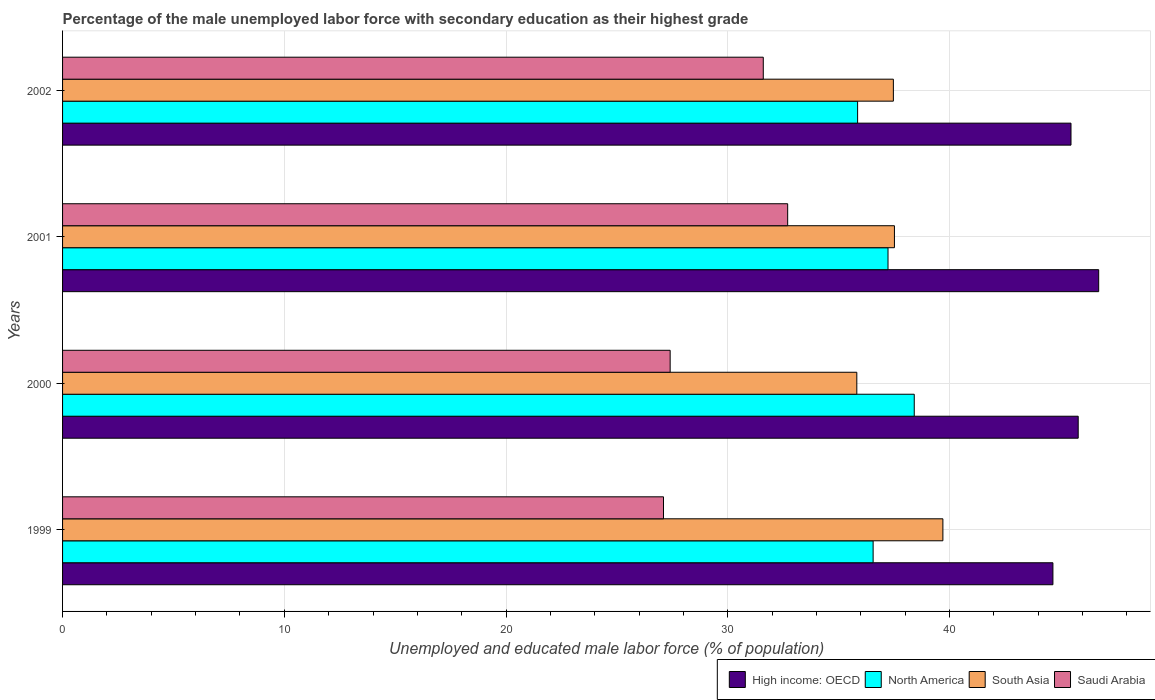How many different coloured bars are there?
Your answer should be compact. 4. In how many cases, is the number of bars for a given year not equal to the number of legend labels?
Make the answer very short. 0. What is the percentage of the unemployed male labor force with secondary education in High income: OECD in 2002?
Make the answer very short. 45.48. Across all years, what is the maximum percentage of the unemployed male labor force with secondary education in Saudi Arabia?
Ensure brevity in your answer.  32.7. Across all years, what is the minimum percentage of the unemployed male labor force with secondary education in Saudi Arabia?
Keep it short and to the point. 27.1. In which year was the percentage of the unemployed male labor force with secondary education in Saudi Arabia minimum?
Your response must be concise. 1999. What is the total percentage of the unemployed male labor force with secondary education in Saudi Arabia in the graph?
Your response must be concise. 118.8. What is the difference between the percentage of the unemployed male labor force with secondary education in Saudi Arabia in 2000 and that in 2001?
Keep it short and to the point. -5.3. What is the difference between the percentage of the unemployed male labor force with secondary education in High income: OECD in 2001 and the percentage of the unemployed male labor force with secondary education in South Asia in 1999?
Provide a succinct answer. 7.03. What is the average percentage of the unemployed male labor force with secondary education in Saudi Arabia per year?
Your response must be concise. 29.7. In the year 2002, what is the difference between the percentage of the unemployed male labor force with secondary education in Saudi Arabia and percentage of the unemployed male labor force with secondary education in South Asia?
Make the answer very short. -5.87. In how many years, is the percentage of the unemployed male labor force with secondary education in High income: OECD greater than 30 %?
Provide a succinct answer. 4. What is the ratio of the percentage of the unemployed male labor force with secondary education in North America in 1999 to that in 2002?
Provide a succinct answer. 1.02. What is the difference between the highest and the second highest percentage of the unemployed male labor force with secondary education in High income: OECD?
Your response must be concise. 0.92. What is the difference between the highest and the lowest percentage of the unemployed male labor force with secondary education in Saudi Arabia?
Offer a very short reply. 5.6. Is it the case that in every year, the sum of the percentage of the unemployed male labor force with secondary education in South Asia and percentage of the unemployed male labor force with secondary education in Saudi Arabia is greater than the sum of percentage of the unemployed male labor force with secondary education in North America and percentage of the unemployed male labor force with secondary education in High income: OECD?
Your response must be concise. No. What does the 4th bar from the top in 1999 represents?
Provide a succinct answer. High income: OECD. Is it the case that in every year, the sum of the percentage of the unemployed male labor force with secondary education in Saudi Arabia and percentage of the unemployed male labor force with secondary education in High income: OECD is greater than the percentage of the unemployed male labor force with secondary education in North America?
Give a very brief answer. Yes. Are all the bars in the graph horizontal?
Offer a very short reply. Yes. How many years are there in the graph?
Your answer should be very brief. 4. Does the graph contain any zero values?
Your answer should be very brief. No. Does the graph contain grids?
Provide a succinct answer. Yes. How many legend labels are there?
Offer a terse response. 4. How are the legend labels stacked?
Offer a very short reply. Horizontal. What is the title of the graph?
Your answer should be compact. Percentage of the male unemployed labor force with secondary education as their highest grade. What is the label or title of the X-axis?
Your answer should be very brief. Unemployed and educated male labor force (% of population). What is the label or title of the Y-axis?
Offer a terse response. Years. What is the Unemployed and educated male labor force (% of population) in High income: OECD in 1999?
Provide a short and direct response. 44.66. What is the Unemployed and educated male labor force (% of population) of North America in 1999?
Make the answer very short. 36.55. What is the Unemployed and educated male labor force (% of population) in South Asia in 1999?
Your response must be concise. 39.7. What is the Unemployed and educated male labor force (% of population) of Saudi Arabia in 1999?
Offer a very short reply. 27.1. What is the Unemployed and educated male labor force (% of population) of High income: OECD in 2000?
Provide a succinct answer. 45.8. What is the Unemployed and educated male labor force (% of population) of North America in 2000?
Give a very brief answer. 38.41. What is the Unemployed and educated male labor force (% of population) of South Asia in 2000?
Ensure brevity in your answer.  35.82. What is the Unemployed and educated male labor force (% of population) of Saudi Arabia in 2000?
Keep it short and to the point. 27.4. What is the Unemployed and educated male labor force (% of population) of High income: OECD in 2001?
Ensure brevity in your answer.  46.73. What is the Unemployed and educated male labor force (% of population) of North America in 2001?
Make the answer very short. 37.22. What is the Unemployed and educated male labor force (% of population) in South Asia in 2001?
Make the answer very short. 37.52. What is the Unemployed and educated male labor force (% of population) of Saudi Arabia in 2001?
Your response must be concise. 32.7. What is the Unemployed and educated male labor force (% of population) of High income: OECD in 2002?
Give a very brief answer. 45.48. What is the Unemployed and educated male labor force (% of population) of North America in 2002?
Offer a terse response. 35.85. What is the Unemployed and educated male labor force (% of population) of South Asia in 2002?
Give a very brief answer. 37.47. What is the Unemployed and educated male labor force (% of population) of Saudi Arabia in 2002?
Provide a succinct answer. 31.6. Across all years, what is the maximum Unemployed and educated male labor force (% of population) of High income: OECD?
Ensure brevity in your answer.  46.73. Across all years, what is the maximum Unemployed and educated male labor force (% of population) in North America?
Give a very brief answer. 38.41. Across all years, what is the maximum Unemployed and educated male labor force (% of population) of South Asia?
Offer a terse response. 39.7. Across all years, what is the maximum Unemployed and educated male labor force (% of population) in Saudi Arabia?
Ensure brevity in your answer.  32.7. Across all years, what is the minimum Unemployed and educated male labor force (% of population) in High income: OECD?
Provide a succinct answer. 44.66. Across all years, what is the minimum Unemployed and educated male labor force (% of population) in North America?
Provide a short and direct response. 35.85. Across all years, what is the minimum Unemployed and educated male labor force (% of population) in South Asia?
Ensure brevity in your answer.  35.82. Across all years, what is the minimum Unemployed and educated male labor force (% of population) in Saudi Arabia?
Your answer should be compact. 27.1. What is the total Unemployed and educated male labor force (% of population) of High income: OECD in the graph?
Offer a terse response. 182.67. What is the total Unemployed and educated male labor force (% of population) in North America in the graph?
Your answer should be very brief. 148.04. What is the total Unemployed and educated male labor force (% of population) in South Asia in the graph?
Give a very brief answer. 150.5. What is the total Unemployed and educated male labor force (% of population) of Saudi Arabia in the graph?
Your response must be concise. 118.8. What is the difference between the Unemployed and educated male labor force (% of population) of High income: OECD in 1999 and that in 2000?
Offer a terse response. -1.14. What is the difference between the Unemployed and educated male labor force (% of population) in North America in 1999 and that in 2000?
Provide a short and direct response. -1.85. What is the difference between the Unemployed and educated male labor force (% of population) of South Asia in 1999 and that in 2000?
Ensure brevity in your answer.  3.88. What is the difference between the Unemployed and educated male labor force (% of population) of Saudi Arabia in 1999 and that in 2000?
Your answer should be very brief. -0.3. What is the difference between the Unemployed and educated male labor force (% of population) in High income: OECD in 1999 and that in 2001?
Keep it short and to the point. -2.06. What is the difference between the Unemployed and educated male labor force (% of population) in North America in 1999 and that in 2001?
Ensure brevity in your answer.  -0.67. What is the difference between the Unemployed and educated male labor force (% of population) of South Asia in 1999 and that in 2001?
Offer a terse response. 2.19. What is the difference between the Unemployed and educated male labor force (% of population) of Saudi Arabia in 1999 and that in 2001?
Provide a short and direct response. -5.6. What is the difference between the Unemployed and educated male labor force (% of population) in High income: OECD in 1999 and that in 2002?
Provide a succinct answer. -0.82. What is the difference between the Unemployed and educated male labor force (% of population) in North America in 1999 and that in 2002?
Keep it short and to the point. 0.7. What is the difference between the Unemployed and educated male labor force (% of population) of South Asia in 1999 and that in 2002?
Provide a succinct answer. 2.23. What is the difference between the Unemployed and educated male labor force (% of population) in High income: OECD in 2000 and that in 2001?
Keep it short and to the point. -0.92. What is the difference between the Unemployed and educated male labor force (% of population) in North America in 2000 and that in 2001?
Offer a terse response. 1.18. What is the difference between the Unemployed and educated male labor force (% of population) of South Asia in 2000 and that in 2001?
Provide a succinct answer. -1.7. What is the difference between the Unemployed and educated male labor force (% of population) of High income: OECD in 2000 and that in 2002?
Provide a succinct answer. 0.32. What is the difference between the Unemployed and educated male labor force (% of population) of North America in 2000 and that in 2002?
Keep it short and to the point. 2.55. What is the difference between the Unemployed and educated male labor force (% of population) of South Asia in 2000 and that in 2002?
Ensure brevity in your answer.  -1.65. What is the difference between the Unemployed and educated male labor force (% of population) in High income: OECD in 2001 and that in 2002?
Provide a short and direct response. 1.25. What is the difference between the Unemployed and educated male labor force (% of population) of North America in 2001 and that in 2002?
Provide a short and direct response. 1.37. What is the difference between the Unemployed and educated male labor force (% of population) in South Asia in 2001 and that in 2002?
Your answer should be compact. 0.05. What is the difference between the Unemployed and educated male labor force (% of population) of Saudi Arabia in 2001 and that in 2002?
Give a very brief answer. 1.1. What is the difference between the Unemployed and educated male labor force (% of population) in High income: OECD in 1999 and the Unemployed and educated male labor force (% of population) in North America in 2000?
Give a very brief answer. 6.25. What is the difference between the Unemployed and educated male labor force (% of population) in High income: OECD in 1999 and the Unemployed and educated male labor force (% of population) in South Asia in 2000?
Your answer should be compact. 8.84. What is the difference between the Unemployed and educated male labor force (% of population) in High income: OECD in 1999 and the Unemployed and educated male labor force (% of population) in Saudi Arabia in 2000?
Ensure brevity in your answer.  17.26. What is the difference between the Unemployed and educated male labor force (% of population) of North America in 1999 and the Unemployed and educated male labor force (% of population) of South Asia in 2000?
Make the answer very short. 0.74. What is the difference between the Unemployed and educated male labor force (% of population) in North America in 1999 and the Unemployed and educated male labor force (% of population) in Saudi Arabia in 2000?
Make the answer very short. 9.15. What is the difference between the Unemployed and educated male labor force (% of population) of High income: OECD in 1999 and the Unemployed and educated male labor force (% of population) of North America in 2001?
Give a very brief answer. 7.44. What is the difference between the Unemployed and educated male labor force (% of population) of High income: OECD in 1999 and the Unemployed and educated male labor force (% of population) of South Asia in 2001?
Your answer should be very brief. 7.15. What is the difference between the Unemployed and educated male labor force (% of population) in High income: OECD in 1999 and the Unemployed and educated male labor force (% of population) in Saudi Arabia in 2001?
Make the answer very short. 11.96. What is the difference between the Unemployed and educated male labor force (% of population) in North America in 1999 and the Unemployed and educated male labor force (% of population) in South Asia in 2001?
Your answer should be compact. -0.96. What is the difference between the Unemployed and educated male labor force (% of population) in North America in 1999 and the Unemployed and educated male labor force (% of population) in Saudi Arabia in 2001?
Give a very brief answer. 3.85. What is the difference between the Unemployed and educated male labor force (% of population) of South Asia in 1999 and the Unemployed and educated male labor force (% of population) of Saudi Arabia in 2001?
Keep it short and to the point. 7. What is the difference between the Unemployed and educated male labor force (% of population) in High income: OECD in 1999 and the Unemployed and educated male labor force (% of population) in North America in 2002?
Offer a terse response. 8.81. What is the difference between the Unemployed and educated male labor force (% of population) of High income: OECD in 1999 and the Unemployed and educated male labor force (% of population) of South Asia in 2002?
Your answer should be very brief. 7.2. What is the difference between the Unemployed and educated male labor force (% of population) of High income: OECD in 1999 and the Unemployed and educated male labor force (% of population) of Saudi Arabia in 2002?
Keep it short and to the point. 13.06. What is the difference between the Unemployed and educated male labor force (% of population) in North America in 1999 and the Unemployed and educated male labor force (% of population) in South Asia in 2002?
Offer a terse response. -0.91. What is the difference between the Unemployed and educated male labor force (% of population) of North America in 1999 and the Unemployed and educated male labor force (% of population) of Saudi Arabia in 2002?
Offer a terse response. 4.95. What is the difference between the Unemployed and educated male labor force (% of population) in South Asia in 1999 and the Unemployed and educated male labor force (% of population) in Saudi Arabia in 2002?
Make the answer very short. 8.1. What is the difference between the Unemployed and educated male labor force (% of population) in High income: OECD in 2000 and the Unemployed and educated male labor force (% of population) in North America in 2001?
Keep it short and to the point. 8.58. What is the difference between the Unemployed and educated male labor force (% of population) in High income: OECD in 2000 and the Unemployed and educated male labor force (% of population) in South Asia in 2001?
Your response must be concise. 8.29. What is the difference between the Unemployed and educated male labor force (% of population) of High income: OECD in 2000 and the Unemployed and educated male labor force (% of population) of Saudi Arabia in 2001?
Make the answer very short. 13.1. What is the difference between the Unemployed and educated male labor force (% of population) in North America in 2000 and the Unemployed and educated male labor force (% of population) in South Asia in 2001?
Your answer should be compact. 0.89. What is the difference between the Unemployed and educated male labor force (% of population) of North America in 2000 and the Unemployed and educated male labor force (% of population) of Saudi Arabia in 2001?
Provide a succinct answer. 5.71. What is the difference between the Unemployed and educated male labor force (% of population) in South Asia in 2000 and the Unemployed and educated male labor force (% of population) in Saudi Arabia in 2001?
Provide a succinct answer. 3.12. What is the difference between the Unemployed and educated male labor force (% of population) in High income: OECD in 2000 and the Unemployed and educated male labor force (% of population) in North America in 2002?
Offer a terse response. 9.95. What is the difference between the Unemployed and educated male labor force (% of population) in High income: OECD in 2000 and the Unemployed and educated male labor force (% of population) in South Asia in 2002?
Provide a succinct answer. 8.34. What is the difference between the Unemployed and educated male labor force (% of population) of High income: OECD in 2000 and the Unemployed and educated male labor force (% of population) of Saudi Arabia in 2002?
Provide a short and direct response. 14.2. What is the difference between the Unemployed and educated male labor force (% of population) in North America in 2000 and the Unemployed and educated male labor force (% of population) in South Asia in 2002?
Your answer should be compact. 0.94. What is the difference between the Unemployed and educated male labor force (% of population) of North America in 2000 and the Unemployed and educated male labor force (% of population) of Saudi Arabia in 2002?
Make the answer very short. 6.81. What is the difference between the Unemployed and educated male labor force (% of population) in South Asia in 2000 and the Unemployed and educated male labor force (% of population) in Saudi Arabia in 2002?
Give a very brief answer. 4.22. What is the difference between the Unemployed and educated male labor force (% of population) in High income: OECD in 2001 and the Unemployed and educated male labor force (% of population) in North America in 2002?
Your answer should be compact. 10.87. What is the difference between the Unemployed and educated male labor force (% of population) of High income: OECD in 2001 and the Unemployed and educated male labor force (% of population) of South Asia in 2002?
Your response must be concise. 9.26. What is the difference between the Unemployed and educated male labor force (% of population) in High income: OECD in 2001 and the Unemployed and educated male labor force (% of population) in Saudi Arabia in 2002?
Give a very brief answer. 15.13. What is the difference between the Unemployed and educated male labor force (% of population) of North America in 2001 and the Unemployed and educated male labor force (% of population) of South Asia in 2002?
Your answer should be compact. -0.24. What is the difference between the Unemployed and educated male labor force (% of population) of North America in 2001 and the Unemployed and educated male labor force (% of population) of Saudi Arabia in 2002?
Provide a succinct answer. 5.62. What is the difference between the Unemployed and educated male labor force (% of population) of South Asia in 2001 and the Unemployed and educated male labor force (% of population) of Saudi Arabia in 2002?
Your answer should be compact. 5.92. What is the average Unemployed and educated male labor force (% of population) in High income: OECD per year?
Provide a short and direct response. 45.67. What is the average Unemployed and educated male labor force (% of population) of North America per year?
Offer a terse response. 37.01. What is the average Unemployed and educated male labor force (% of population) in South Asia per year?
Your response must be concise. 37.62. What is the average Unemployed and educated male labor force (% of population) of Saudi Arabia per year?
Ensure brevity in your answer.  29.7. In the year 1999, what is the difference between the Unemployed and educated male labor force (% of population) in High income: OECD and Unemployed and educated male labor force (% of population) in North America?
Provide a succinct answer. 8.11. In the year 1999, what is the difference between the Unemployed and educated male labor force (% of population) of High income: OECD and Unemployed and educated male labor force (% of population) of South Asia?
Give a very brief answer. 4.96. In the year 1999, what is the difference between the Unemployed and educated male labor force (% of population) of High income: OECD and Unemployed and educated male labor force (% of population) of Saudi Arabia?
Give a very brief answer. 17.56. In the year 1999, what is the difference between the Unemployed and educated male labor force (% of population) in North America and Unemployed and educated male labor force (% of population) in South Asia?
Make the answer very short. -3.15. In the year 1999, what is the difference between the Unemployed and educated male labor force (% of population) of North America and Unemployed and educated male labor force (% of population) of Saudi Arabia?
Offer a very short reply. 9.45. In the year 2000, what is the difference between the Unemployed and educated male labor force (% of population) in High income: OECD and Unemployed and educated male labor force (% of population) in North America?
Keep it short and to the point. 7.39. In the year 2000, what is the difference between the Unemployed and educated male labor force (% of population) of High income: OECD and Unemployed and educated male labor force (% of population) of South Asia?
Offer a terse response. 9.98. In the year 2000, what is the difference between the Unemployed and educated male labor force (% of population) in High income: OECD and Unemployed and educated male labor force (% of population) in Saudi Arabia?
Offer a terse response. 18.4. In the year 2000, what is the difference between the Unemployed and educated male labor force (% of population) of North America and Unemployed and educated male labor force (% of population) of South Asia?
Your answer should be very brief. 2.59. In the year 2000, what is the difference between the Unemployed and educated male labor force (% of population) in North America and Unemployed and educated male labor force (% of population) in Saudi Arabia?
Offer a terse response. 11.01. In the year 2000, what is the difference between the Unemployed and educated male labor force (% of population) in South Asia and Unemployed and educated male labor force (% of population) in Saudi Arabia?
Your answer should be compact. 8.42. In the year 2001, what is the difference between the Unemployed and educated male labor force (% of population) of High income: OECD and Unemployed and educated male labor force (% of population) of North America?
Keep it short and to the point. 9.5. In the year 2001, what is the difference between the Unemployed and educated male labor force (% of population) of High income: OECD and Unemployed and educated male labor force (% of population) of South Asia?
Offer a terse response. 9.21. In the year 2001, what is the difference between the Unemployed and educated male labor force (% of population) in High income: OECD and Unemployed and educated male labor force (% of population) in Saudi Arabia?
Keep it short and to the point. 14.03. In the year 2001, what is the difference between the Unemployed and educated male labor force (% of population) in North America and Unemployed and educated male labor force (% of population) in South Asia?
Your answer should be compact. -0.29. In the year 2001, what is the difference between the Unemployed and educated male labor force (% of population) in North America and Unemployed and educated male labor force (% of population) in Saudi Arabia?
Ensure brevity in your answer.  4.52. In the year 2001, what is the difference between the Unemployed and educated male labor force (% of population) in South Asia and Unemployed and educated male labor force (% of population) in Saudi Arabia?
Provide a succinct answer. 4.82. In the year 2002, what is the difference between the Unemployed and educated male labor force (% of population) of High income: OECD and Unemployed and educated male labor force (% of population) of North America?
Your answer should be compact. 9.62. In the year 2002, what is the difference between the Unemployed and educated male labor force (% of population) of High income: OECD and Unemployed and educated male labor force (% of population) of South Asia?
Your answer should be very brief. 8.01. In the year 2002, what is the difference between the Unemployed and educated male labor force (% of population) in High income: OECD and Unemployed and educated male labor force (% of population) in Saudi Arabia?
Provide a short and direct response. 13.88. In the year 2002, what is the difference between the Unemployed and educated male labor force (% of population) of North America and Unemployed and educated male labor force (% of population) of South Asia?
Your answer should be very brief. -1.61. In the year 2002, what is the difference between the Unemployed and educated male labor force (% of population) of North America and Unemployed and educated male labor force (% of population) of Saudi Arabia?
Your answer should be very brief. 4.25. In the year 2002, what is the difference between the Unemployed and educated male labor force (% of population) in South Asia and Unemployed and educated male labor force (% of population) in Saudi Arabia?
Offer a very short reply. 5.87. What is the ratio of the Unemployed and educated male labor force (% of population) in High income: OECD in 1999 to that in 2000?
Ensure brevity in your answer.  0.98. What is the ratio of the Unemployed and educated male labor force (% of population) of North America in 1999 to that in 2000?
Make the answer very short. 0.95. What is the ratio of the Unemployed and educated male labor force (% of population) in South Asia in 1999 to that in 2000?
Offer a very short reply. 1.11. What is the ratio of the Unemployed and educated male labor force (% of population) in Saudi Arabia in 1999 to that in 2000?
Your answer should be compact. 0.99. What is the ratio of the Unemployed and educated male labor force (% of population) in High income: OECD in 1999 to that in 2001?
Offer a terse response. 0.96. What is the ratio of the Unemployed and educated male labor force (% of population) in North America in 1999 to that in 2001?
Keep it short and to the point. 0.98. What is the ratio of the Unemployed and educated male labor force (% of population) of South Asia in 1999 to that in 2001?
Keep it short and to the point. 1.06. What is the ratio of the Unemployed and educated male labor force (% of population) in Saudi Arabia in 1999 to that in 2001?
Your response must be concise. 0.83. What is the ratio of the Unemployed and educated male labor force (% of population) of High income: OECD in 1999 to that in 2002?
Make the answer very short. 0.98. What is the ratio of the Unemployed and educated male labor force (% of population) of North America in 1999 to that in 2002?
Offer a terse response. 1.02. What is the ratio of the Unemployed and educated male labor force (% of population) in South Asia in 1999 to that in 2002?
Make the answer very short. 1.06. What is the ratio of the Unemployed and educated male labor force (% of population) of Saudi Arabia in 1999 to that in 2002?
Your answer should be very brief. 0.86. What is the ratio of the Unemployed and educated male labor force (% of population) of High income: OECD in 2000 to that in 2001?
Make the answer very short. 0.98. What is the ratio of the Unemployed and educated male labor force (% of population) of North America in 2000 to that in 2001?
Make the answer very short. 1.03. What is the ratio of the Unemployed and educated male labor force (% of population) of South Asia in 2000 to that in 2001?
Give a very brief answer. 0.95. What is the ratio of the Unemployed and educated male labor force (% of population) of Saudi Arabia in 2000 to that in 2001?
Provide a short and direct response. 0.84. What is the ratio of the Unemployed and educated male labor force (% of population) in High income: OECD in 2000 to that in 2002?
Provide a short and direct response. 1.01. What is the ratio of the Unemployed and educated male labor force (% of population) in North America in 2000 to that in 2002?
Your answer should be very brief. 1.07. What is the ratio of the Unemployed and educated male labor force (% of population) of South Asia in 2000 to that in 2002?
Offer a terse response. 0.96. What is the ratio of the Unemployed and educated male labor force (% of population) in Saudi Arabia in 2000 to that in 2002?
Your response must be concise. 0.87. What is the ratio of the Unemployed and educated male labor force (% of population) of High income: OECD in 2001 to that in 2002?
Keep it short and to the point. 1.03. What is the ratio of the Unemployed and educated male labor force (% of population) of North America in 2001 to that in 2002?
Ensure brevity in your answer.  1.04. What is the ratio of the Unemployed and educated male labor force (% of population) in Saudi Arabia in 2001 to that in 2002?
Provide a short and direct response. 1.03. What is the difference between the highest and the second highest Unemployed and educated male labor force (% of population) in High income: OECD?
Your answer should be compact. 0.92. What is the difference between the highest and the second highest Unemployed and educated male labor force (% of population) in North America?
Your answer should be very brief. 1.18. What is the difference between the highest and the second highest Unemployed and educated male labor force (% of population) in South Asia?
Give a very brief answer. 2.19. What is the difference between the highest and the lowest Unemployed and educated male labor force (% of population) in High income: OECD?
Your response must be concise. 2.06. What is the difference between the highest and the lowest Unemployed and educated male labor force (% of population) of North America?
Provide a succinct answer. 2.55. What is the difference between the highest and the lowest Unemployed and educated male labor force (% of population) in South Asia?
Your answer should be compact. 3.88. 